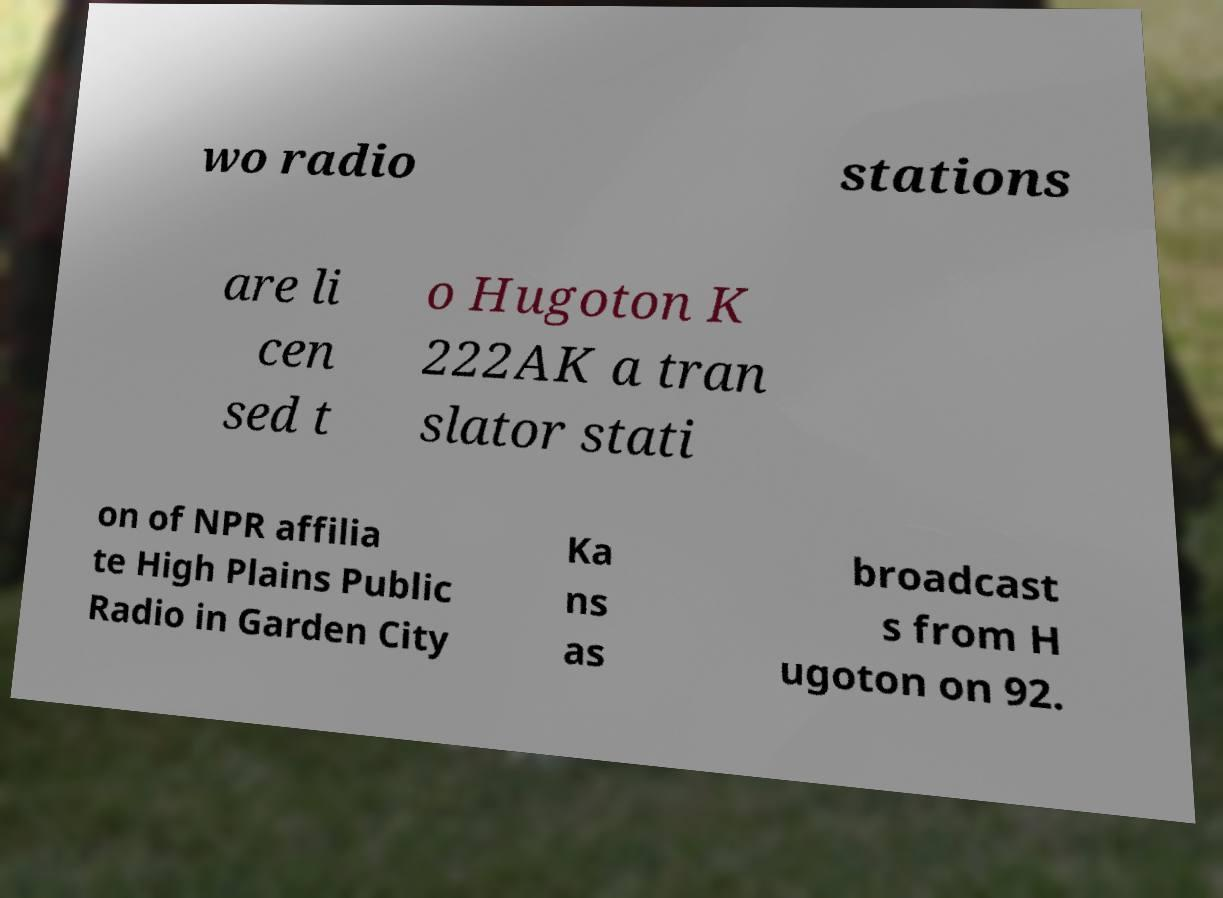Can you accurately transcribe the text from the provided image for me? wo radio stations are li cen sed t o Hugoton K 222AK a tran slator stati on of NPR affilia te High Plains Public Radio in Garden City Ka ns as broadcast s from H ugoton on 92. 